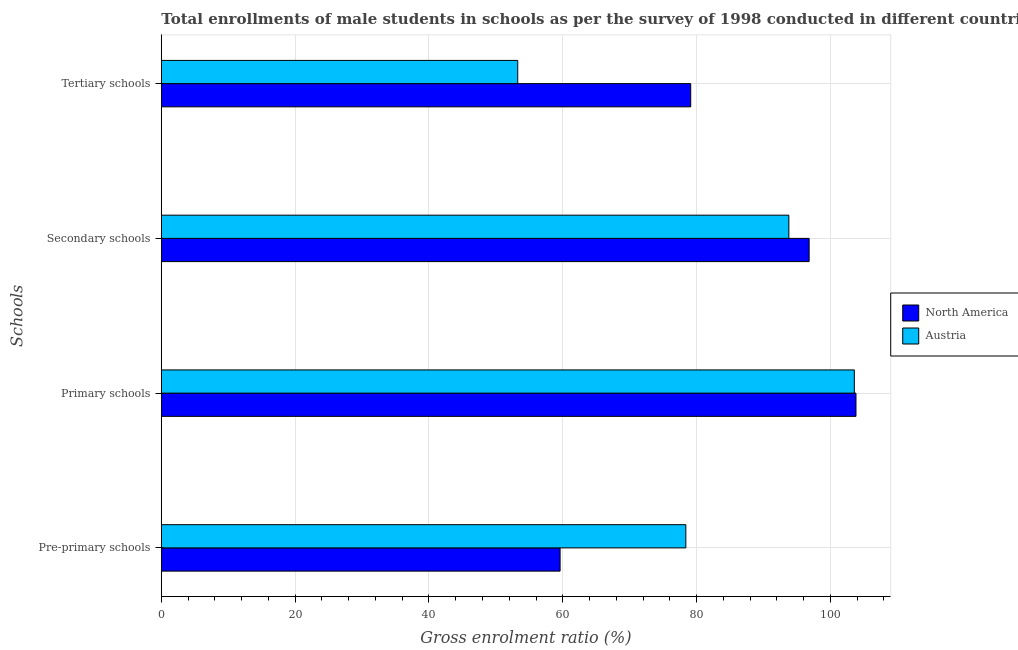How many groups of bars are there?
Make the answer very short. 4. Are the number of bars per tick equal to the number of legend labels?
Keep it short and to the point. Yes. How many bars are there on the 4th tick from the bottom?
Your answer should be compact. 2. What is the label of the 2nd group of bars from the top?
Provide a succinct answer. Secondary schools. What is the gross enrolment ratio(male) in pre-primary schools in North America?
Ensure brevity in your answer.  59.6. Across all countries, what is the maximum gross enrolment ratio(male) in primary schools?
Give a very brief answer. 103.82. Across all countries, what is the minimum gross enrolment ratio(male) in tertiary schools?
Your response must be concise. 53.27. In which country was the gross enrolment ratio(male) in pre-primary schools minimum?
Give a very brief answer. North America. What is the total gross enrolment ratio(male) in tertiary schools in the graph?
Provide a short and direct response. 132.39. What is the difference between the gross enrolment ratio(male) in primary schools in North America and that in Austria?
Provide a succinct answer. 0.25. What is the difference between the gross enrolment ratio(male) in pre-primary schools in North America and the gross enrolment ratio(male) in primary schools in Austria?
Your answer should be compact. -43.98. What is the average gross enrolment ratio(male) in tertiary schools per country?
Give a very brief answer. 66.2. What is the difference between the gross enrolment ratio(male) in secondary schools and gross enrolment ratio(male) in pre-primary schools in North America?
Your response must be concise. 37.22. What is the ratio of the gross enrolment ratio(male) in pre-primary schools in North America to that in Austria?
Offer a terse response. 0.76. Is the gross enrolment ratio(male) in primary schools in Austria less than that in North America?
Keep it short and to the point. Yes. What is the difference between the highest and the second highest gross enrolment ratio(male) in tertiary schools?
Keep it short and to the point. 25.85. What is the difference between the highest and the lowest gross enrolment ratio(male) in tertiary schools?
Keep it short and to the point. 25.85. In how many countries, is the gross enrolment ratio(male) in pre-primary schools greater than the average gross enrolment ratio(male) in pre-primary schools taken over all countries?
Your answer should be very brief. 1. Is the sum of the gross enrolment ratio(male) in tertiary schools in Austria and North America greater than the maximum gross enrolment ratio(male) in primary schools across all countries?
Offer a terse response. Yes. What does the 1st bar from the bottom in Secondary schools represents?
Make the answer very short. North America. Is it the case that in every country, the sum of the gross enrolment ratio(male) in pre-primary schools and gross enrolment ratio(male) in primary schools is greater than the gross enrolment ratio(male) in secondary schools?
Make the answer very short. Yes. How many bars are there?
Provide a short and direct response. 8. Where does the legend appear in the graph?
Offer a terse response. Center right. How many legend labels are there?
Offer a very short reply. 2. What is the title of the graph?
Offer a terse response. Total enrollments of male students in schools as per the survey of 1998 conducted in different countries. Does "Small states" appear as one of the legend labels in the graph?
Provide a succinct answer. No. What is the label or title of the Y-axis?
Your answer should be very brief. Schools. What is the Gross enrolment ratio (%) in North America in Pre-primary schools?
Keep it short and to the point. 59.6. What is the Gross enrolment ratio (%) in Austria in Pre-primary schools?
Make the answer very short. 78.4. What is the Gross enrolment ratio (%) in North America in Primary schools?
Give a very brief answer. 103.82. What is the Gross enrolment ratio (%) in Austria in Primary schools?
Your response must be concise. 103.58. What is the Gross enrolment ratio (%) of North America in Secondary schools?
Your answer should be compact. 96.82. What is the Gross enrolment ratio (%) of Austria in Secondary schools?
Offer a terse response. 93.79. What is the Gross enrolment ratio (%) of North America in Tertiary schools?
Provide a short and direct response. 79.12. What is the Gross enrolment ratio (%) of Austria in Tertiary schools?
Your answer should be very brief. 53.27. Across all Schools, what is the maximum Gross enrolment ratio (%) of North America?
Provide a succinct answer. 103.82. Across all Schools, what is the maximum Gross enrolment ratio (%) of Austria?
Your answer should be compact. 103.58. Across all Schools, what is the minimum Gross enrolment ratio (%) of North America?
Provide a short and direct response. 59.6. Across all Schools, what is the minimum Gross enrolment ratio (%) in Austria?
Keep it short and to the point. 53.27. What is the total Gross enrolment ratio (%) in North America in the graph?
Offer a very short reply. 339.37. What is the total Gross enrolment ratio (%) in Austria in the graph?
Give a very brief answer. 329.04. What is the difference between the Gross enrolment ratio (%) in North America in Pre-primary schools and that in Primary schools?
Offer a terse response. -44.22. What is the difference between the Gross enrolment ratio (%) of Austria in Pre-primary schools and that in Primary schools?
Your answer should be very brief. -25.18. What is the difference between the Gross enrolment ratio (%) in North America in Pre-primary schools and that in Secondary schools?
Keep it short and to the point. -37.22. What is the difference between the Gross enrolment ratio (%) of Austria in Pre-primary schools and that in Secondary schools?
Provide a short and direct response. -15.4. What is the difference between the Gross enrolment ratio (%) in North America in Pre-primary schools and that in Tertiary schools?
Keep it short and to the point. -19.52. What is the difference between the Gross enrolment ratio (%) of Austria in Pre-primary schools and that in Tertiary schools?
Provide a short and direct response. 25.13. What is the difference between the Gross enrolment ratio (%) of North America in Primary schools and that in Secondary schools?
Offer a terse response. 7. What is the difference between the Gross enrolment ratio (%) in Austria in Primary schools and that in Secondary schools?
Offer a terse response. 9.79. What is the difference between the Gross enrolment ratio (%) of North America in Primary schools and that in Tertiary schools?
Give a very brief answer. 24.7. What is the difference between the Gross enrolment ratio (%) of Austria in Primary schools and that in Tertiary schools?
Give a very brief answer. 50.31. What is the difference between the Gross enrolment ratio (%) in North America in Secondary schools and that in Tertiary schools?
Provide a succinct answer. 17.7. What is the difference between the Gross enrolment ratio (%) in Austria in Secondary schools and that in Tertiary schools?
Offer a terse response. 40.52. What is the difference between the Gross enrolment ratio (%) in North America in Pre-primary schools and the Gross enrolment ratio (%) in Austria in Primary schools?
Provide a succinct answer. -43.98. What is the difference between the Gross enrolment ratio (%) of North America in Pre-primary schools and the Gross enrolment ratio (%) of Austria in Secondary schools?
Provide a succinct answer. -34.19. What is the difference between the Gross enrolment ratio (%) of North America in Pre-primary schools and the Gross enrolment ratio (%) of Austria in Tertiary schools?
Keep it short and to the point. 6.33. What is the difference between the Gross enrolment ratio (%) in North America in Primary schools and the Gross enrolment ratio (%) in Austria in Secondary schools?
Provide a succinct answer. 10.03. What is the difference between the Gross enrolment ratio (%) of North America in Primary schools and the Gross enrolment ratio (%) of Austria in Tertiary schools?
Your response must be concise. 50.55. What is the difference between the Gross enrolment ratio (%) in North America in Secondary schools and the Gross enrolment ratio (%) in Austria in Tertiary schools?
Provide a succinct answer. 43.55. What is the average Gross enrolment ratio (%) in North America per Schools?
Your response must be concise. 84.84. What is the average Gross enrolment ratio (%) of Austria per Schools?
Ensure brevity in your answer.  82.26. What is the difference between the Gross enrolment ratio (%) of North America and Gross enrolment ratio (%) of Austria in Pre-primary schools?
Offer a terse response. -18.79. What is the difference between the Gross enrolment ratio (%) of North America and Gross enrolment ratio (%) of Austria in Primary schools?
Provide a short and direct response. 0.25. What is the difference between the Gross enrolment ratio (%) of North America and Gross enrolment ratio (%) of Austria in Secondary schools?
Offer a terse response. 3.03. What is the difference between the Gross enrolment ratio (%) in North America and Gross enrolment ratio (%) in Austria in Tertiary schools?
Give a very brief answer. 25.85. What is the ratio of the Gross enrolment ratio (%) of North America in Pre-primary schools to that in Primary schools?
Provide a short and direct response. 0.57. What is the ratio of the Gross enrolment ratio (%) of Austria in Pre-primary schools to that in Primary schools?
Make the answer very short. 0.76. What is the ratio of the Gross enrolment ratio (%) in North America in Pre-primary schools to that in Secondary schools?
Provide a succinct answer. 0.62. What is the ratio of the Gross enrolment ratio (%) in Austria in Pre-primary schools to that in Secondary schools?
Provide a short and direct response. 0.84. What is the ratio of the Gross enrolment ratio (%) of North America in Pre-primary schools to that in Tertiary schools?
Offer a terse response. 0.75. What is the ratio of the Gross enrolment ratio (%) of Austria in Pre-primary schools to that in Tertiary schools?
Offer a very short reply. 1.47. What is the ratio of the Gross enrolment ratio (%) of North America in Primary schools to that in Secondary schools?
Your response must be concise. 1.07. What is the ratio of the Gross enrolment ratio (%) in Austria in Primary schools to that in Secondary schools?
Provide a short and direct response. 1.1. What is the ratio of the Gross enrolment ratio (%) in North America in Primary schools to that in Tertiary schools?
Your answer should be very brief. 1.31. What is the ratio of the Gross enrolment ratio (%) of Austria in Primary schools to that in Tertiary schools?
Your response must be concise. 1.94. What is the ratio of the Gross enrolment ratio (%) in North America in Secondary schools to that in Tertiary schools?
Ensure brevity in your answer.  1.22. What is the ratio of the Gross enrolment ratio (%) in Austria in Secondary schools to that in Tertiary schools?
Give a very brief answer. 1.76. What is the difference between the highest and the second highest Gross enrolment ratio (%) of North America?
Your answer should be compact. 7. What is the difference between the highest and the second highest Gross enrolment ratio (%) in Austria?
Your response must be concise. 9.79. What is the difference between the highest and the lowest Gross enrolment ratio (%) in North America?
Ensure brevity in your answer.  44.22. What is the difference between the highest and the lowest Gross enrolment ratio (%) of Austria?
Your response must be concise. 50.31. 